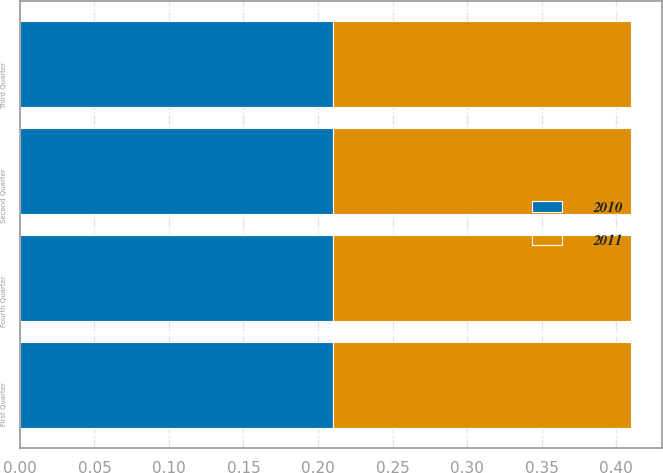<chart> <loc_0><loc_0><loc_500><loc_500><stacked_bar_chart><ecel><fcel>First Quarter<fcel>Second Quarter<fcel>Third Quarter<fcel>Fourth Quarter<nl><fcel>2010<fcel>0.21<fcel>0.21<fcel>0.21<fcel>0.21<nl><fcel>2011<fcel>0.2<fcel>0.2<fcel>0.2<fcel>0.2<nl></chart> 